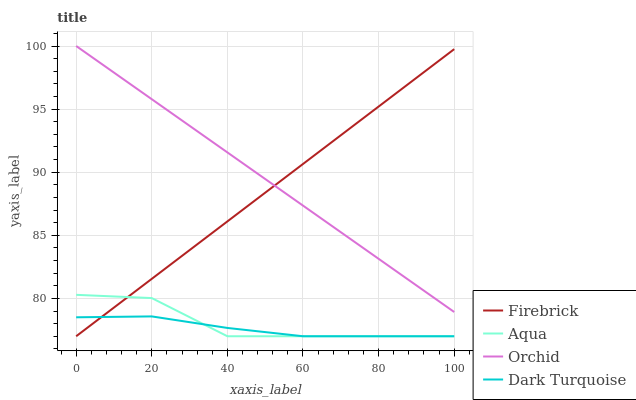Does Firebrick have the minimum area under the curve?
Answer yes or no. No. Does Firebrick have the maximum area under the curve?
Answer yes or no. No. Is Aqua the smoothest?
Answer yes or no. No. Is Firebrick the roughest?
Answer yes or no. No. Does Orchid have the lowest value?
Answer yes or no. No. Does Firebrick have the highest value?
Answer yes or no. No. Is Aqua less than Orchid?
Answer yes or no. Yes. Is Orchid greater than Dark Turquoise?
Answer yes or no. Yes. Does Aqua intersect Orchid?
Answer yes or no. No. 